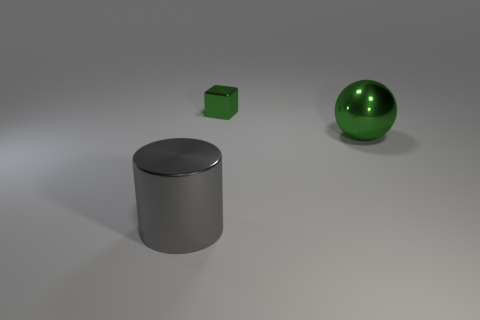Add 1 large cyan metal cylinders. How many objects exist? 4 Subtract all cubes. How many objects are left? 2 Subtract 0 yellow blocks. How many objects are left? 3 Subtract 1 spheres. How many spheres are left? 0 Subtract all cyan balls. Subtract all red cylinders. How many balls are left? 1 Subtract all green objects. Subtract all gray objects. How many objects are left? 0 Add 3 large gray cylinders. How many large gray cylinders are left? 4 Add 2 green shiny balls. How many green shiny balls exist? 3 